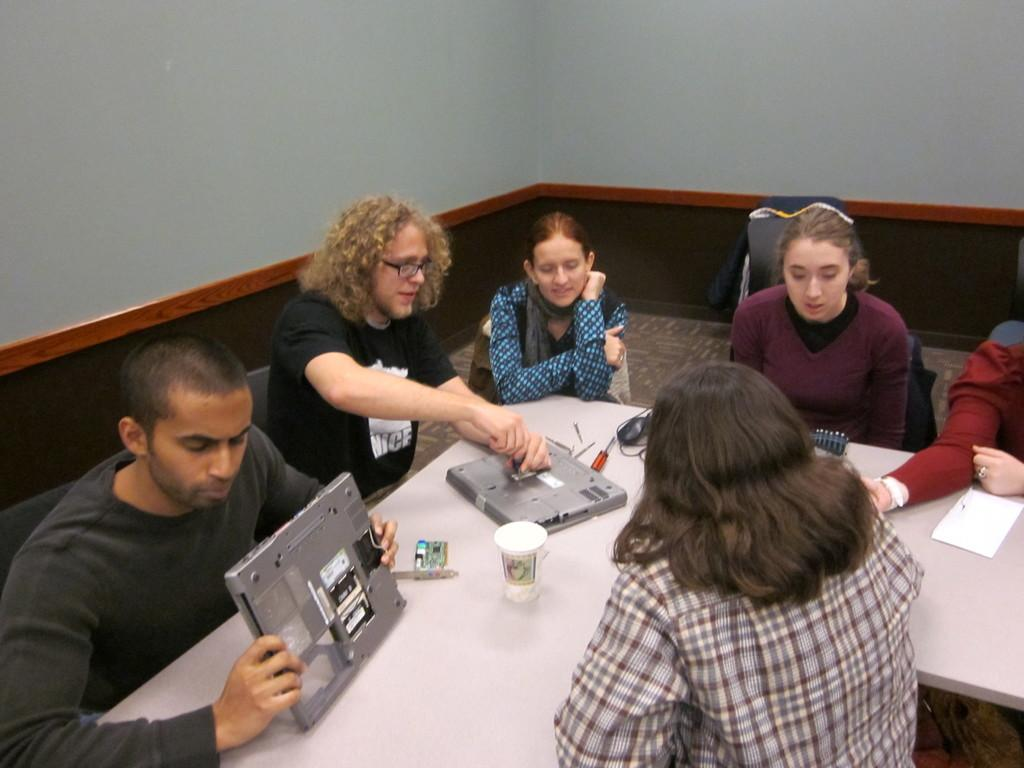How many people are in the image? There is a group of persons in the image. What are the persons in the image doing? The persons are sitting in front of a table. What can be seen on the table in the image? There are objects on the table. What type of songs are the persons singing in the image? There is no indication in the image that the persons are singing songs, so it cannot be determined from the picture. 